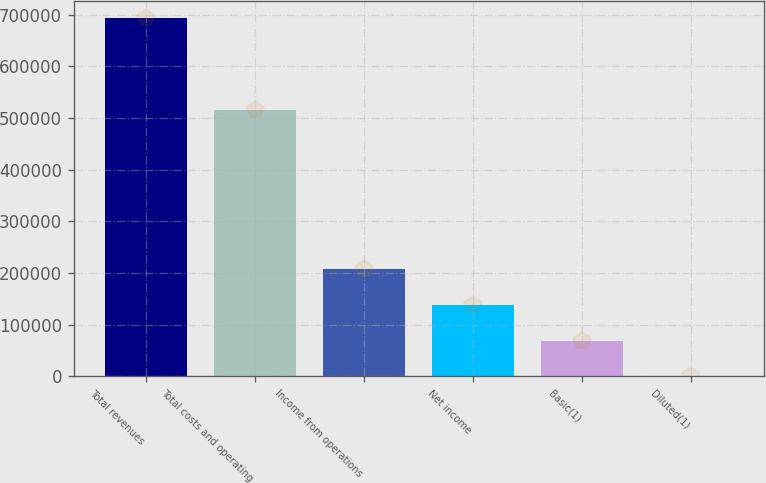<chart> <loc_0><loc_0><loc_500><loc_500><bar_chart><fcel>Total revenues<fcel>Total costs and operating<fcel>Income from operations<fcel>Net income<fcel>Basic(1)<fcel>Diluted(1)<nl><fcel>693020<fcel>515742<fcel>207906<fcel>138604<fcel>69302.4<fcel>0.46<nl></chart> 